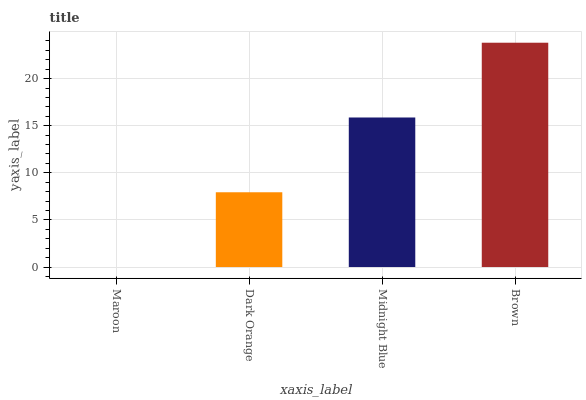Is Maroon the minimum?
Answer yes or no. Yes. Is Brown the maximum?
Answer yes or no. Yes. Is Dark Orange the minimum?
Answer yes or no. No. Is Dark Orange the maximum?
Answer yes or no. No. Is Dark Orange greater than Maroon?
Answer yes or no. Yes. Is Maroon less than Dark Orange?
Answer yes or no. Yes. Is Maroon greater than Dark Orange?
Answer yes or no. No. Is Dark Orange less than Maroon?
Answer yes or no. No. Is Midnight Blue the high median?
Answer yes or no. Yes. Is Dark Orange the low median?
Answer yes or no. Yes. Is Dark Orange the high median?
Answer yes or no. No. Is Brown the low median?
Answer yes or no. No. 